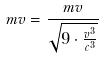Convert formula to latex. <formula><loc_0><loc_0><loc_500><loc_500>m v = \frac { m v } { \sqrt { 9 \cdot \frac { v ^ { 3 } } { c ^ { 3 } } } }</formula> 